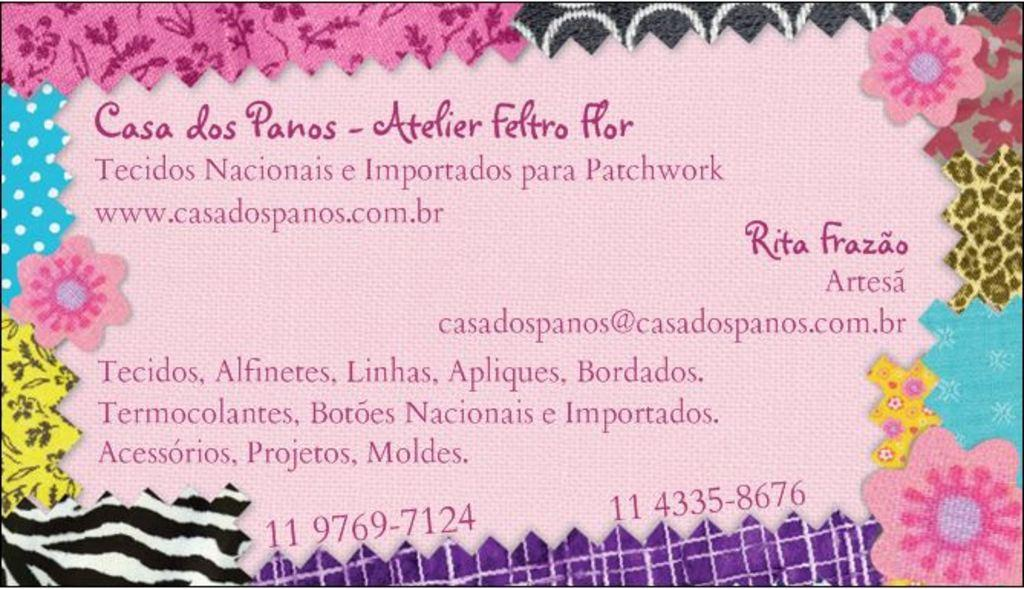What is the main subject of the image? The main subject of the image is a cover page. What can be found on the cover page? The cover page has text on it. Are there any decorative elements on the cover page? Yes, there are flowers on the borders of the cover page. What type of quince is being offered by the actor on the cover page? There is no quince or actor present on the cover page; it only features text and flowers on the borders. 